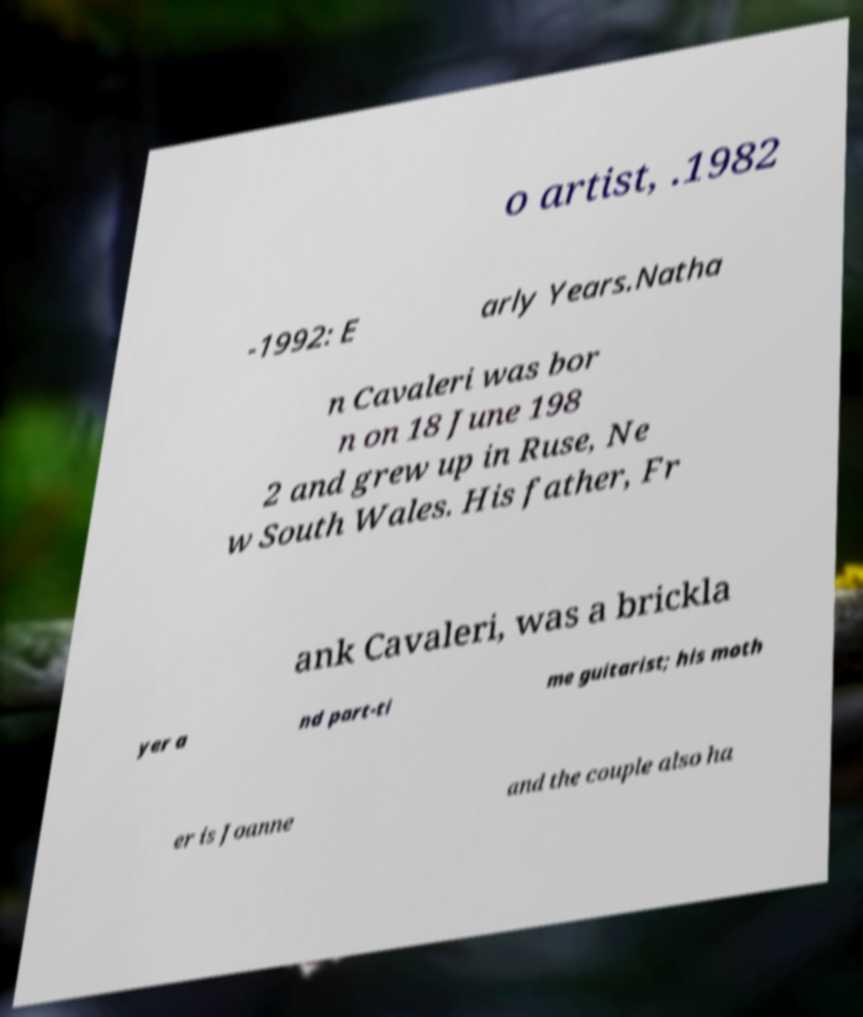Please identify and transcribe the text found in this image. o artist, .1982 -1992: E arly Years.Natha n Cavaleri was bor n on 18 June 198 2 and grew up in Ruse, Ne w South Wales. His father, Fr ank Cavaleri, was a brickla yer a nd part-ti me guitarist; his moth er is Joanne and the couple also ha 